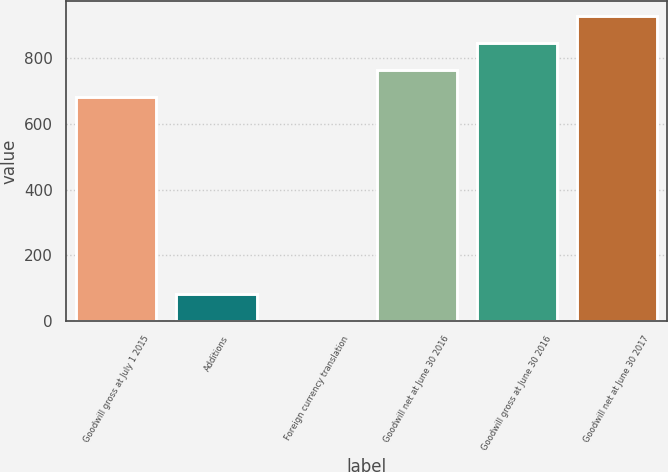<chart> <loc_0><loc_0><loc_500><loc_500><bar_chart><fcel>Goodwill gross at July 1 2015<fcel>Additions<fcel>Foreign currency translation<fcel>Goodwill net at June 30 2016<fcel>Goodwill gross at June 30 2016<fcel>Goodwill net at June 30 2017<nl><fcel>681.4<fcel>82.46<fcel>0.4<fcel>763.46<fcel>845.52<fcel>927.58<nl></chart> 